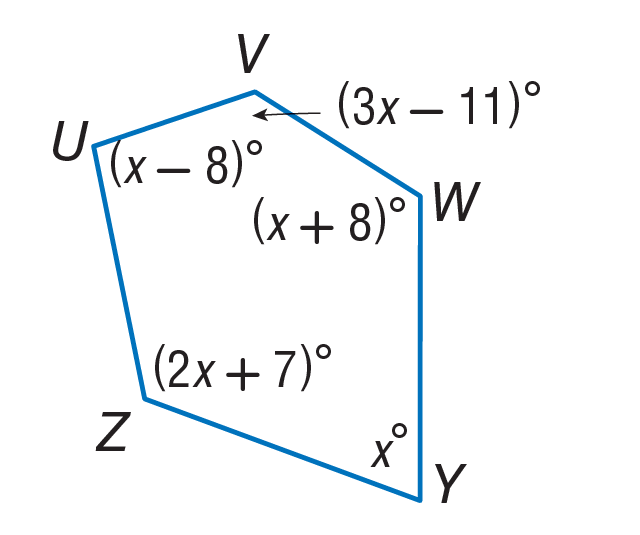Answer the mathemtical geometry problem and directly provide the correct option letter.
Question: Find m \angle U.
Choices: A: 60 B: 68 C: 76 D: 136 A 